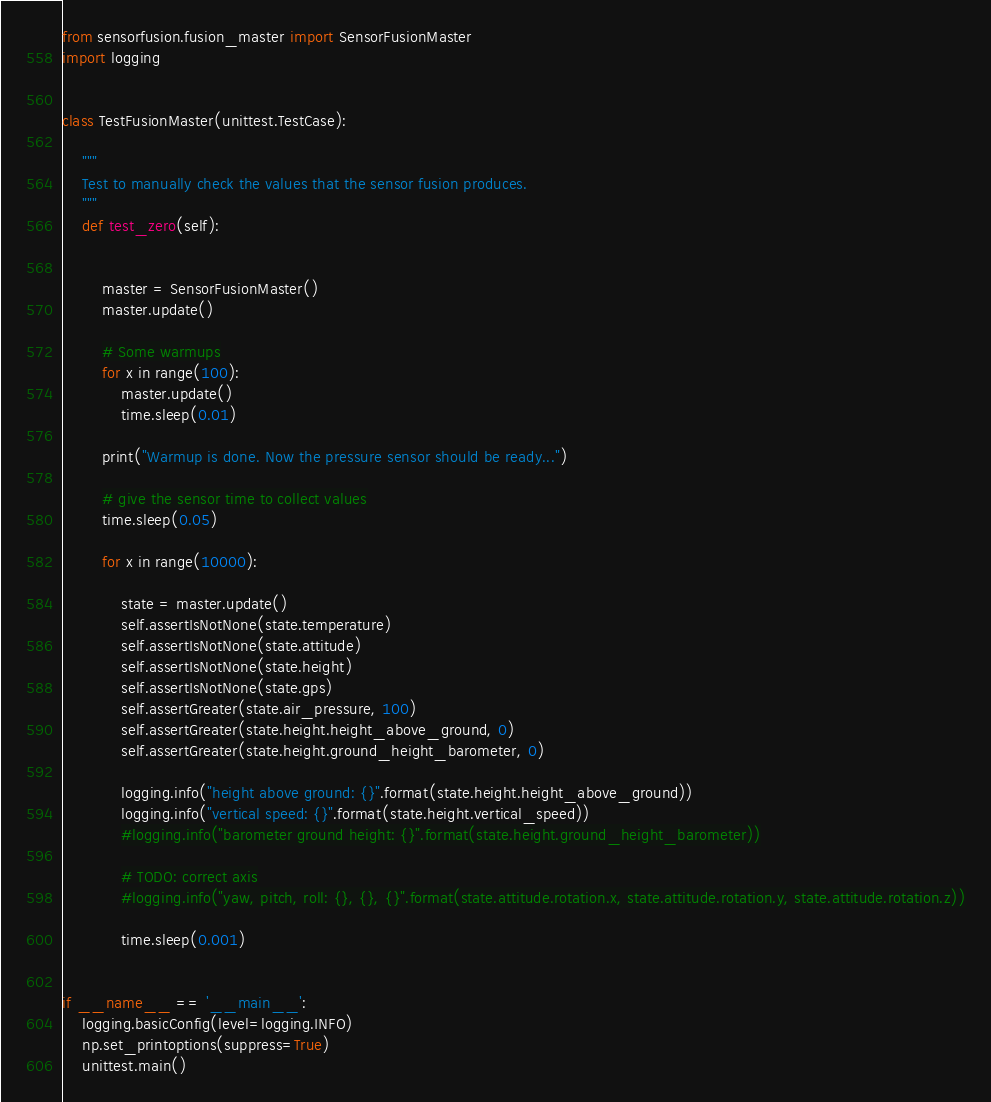Convert code to text. <code><loc_0><loc_0><loc_500><loc_500><_Python_>from sensorfusion.fusion_master import SensorFusionMaster
import logging


class TestFusionMaster(unittest.TestCase):

    """
    Test to manually check the values that the sensor fusion produces.
    """
    def test_zero(self):


        master = SensorFusionMaster()
        master.update()

        # Some warmups
        for x in range(100):
            master.update()
            time.sleep(0.01)

        print("Warmup is done. Now the pressure sensor should be ready...")

        # give the sensor time to collect values
        time.sleep(0.05)

        for x in range(10000):

            state = master.update()
            self.assertIsNotNone(state.temperature)
            self.assertIsNotNone(state.attitude)
            self.assertIsNotNone(state.height)
            self.assertIsNotNone(state.gps)
            self.assertGreater(state.air_pressure, 100)
            self.assertGreater(state.height.height_above_ground, 0)
            self.assertGreater(state.height.ground_height_barometer, 0)

            logging.info("height above ground: {}".format(state.height.height_above_ground))
            logging.info("vertical speed: {}".format(state.height.vertical_speed))
            #logging.info("barometer ground height: {}".format(state.height.ground_height_barometer))

            # TODO: correct axis
            #logging.info("yaw, pitch, roll: {}, {}, {}".format(state.attitude.rotation.x, state.attitude.rotation.y, state.attitude.rotation.z))

            time.sleep(0.001)


if __name__ == '__main__':
    logging.basicConfig(level=logging.INFO)
    np.set_printoptions(suppress=True)
    unittest.main()
</code> 